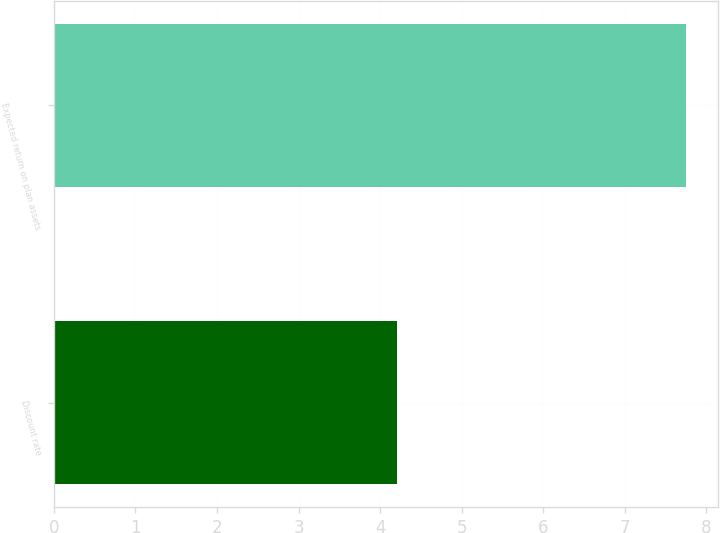Convert chart. <chart><loc_0><loc_0><loc_500><loc_500><bar_chart><fcel>Discount rate<fcel>Expected return on plan assets<nl><fcel>4.21<fcel>7.75<nl></chart> 